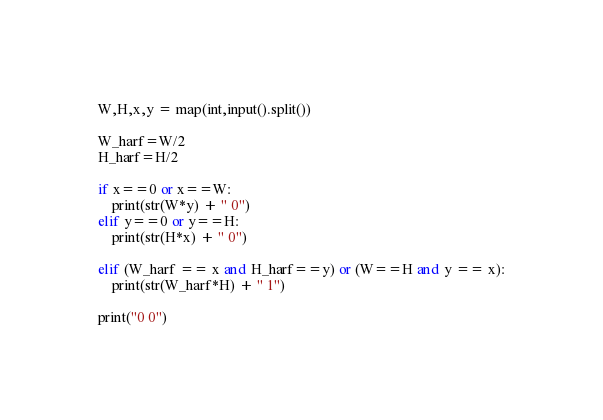Convert code to text. <code><loc_0><loc_0><loc_500><loc_500><_Python_>W,H,x,y = map(int,input().split())

W_harf=W/2
H_harf=H/2

if x==0 or x==W:
    print(str(W*y) + " 0")
elif y==0 or y==H:
    print(str(H*x) + " 0")

elif (W_harf == x and H_harf==y) or (W==H and y == x):
    print(str(W_harf*H) + " 1")
    
print("0 0")</code> 